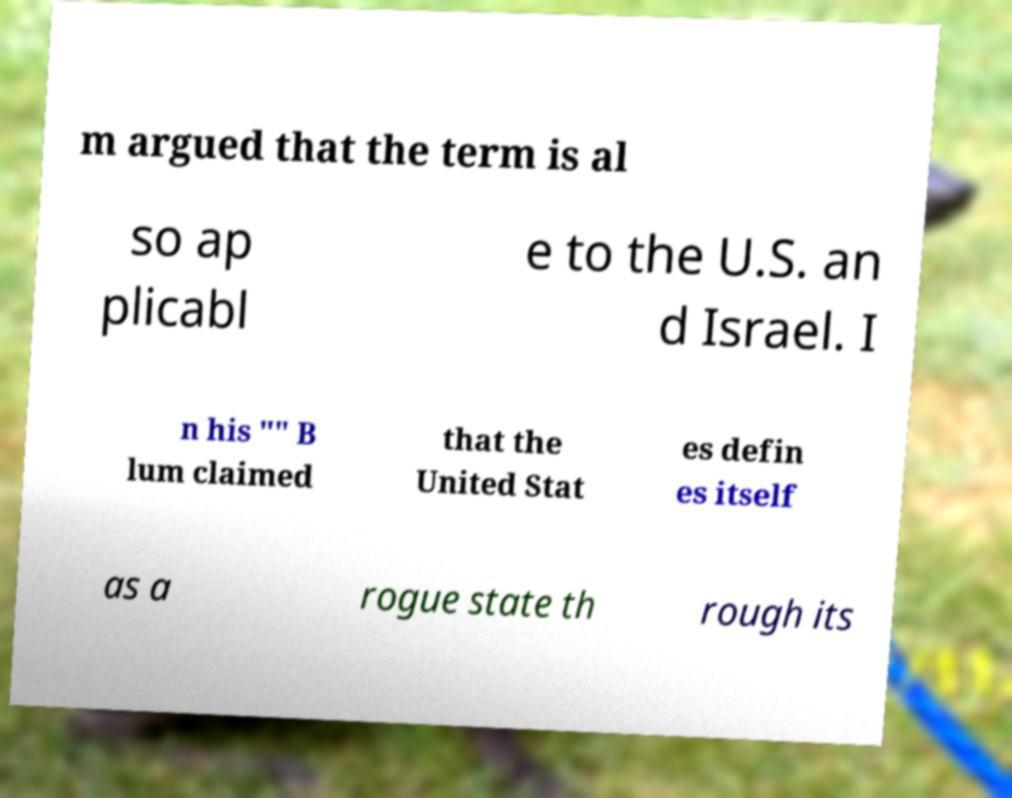Could you assist in decoding the text presented in this image and type it out clearly? m argued that the term is al so ap plicabl e to the U.S. an d Israel. I n his "" B lum claimed that the United Stat es defin es itself as a rogue state th rough its 